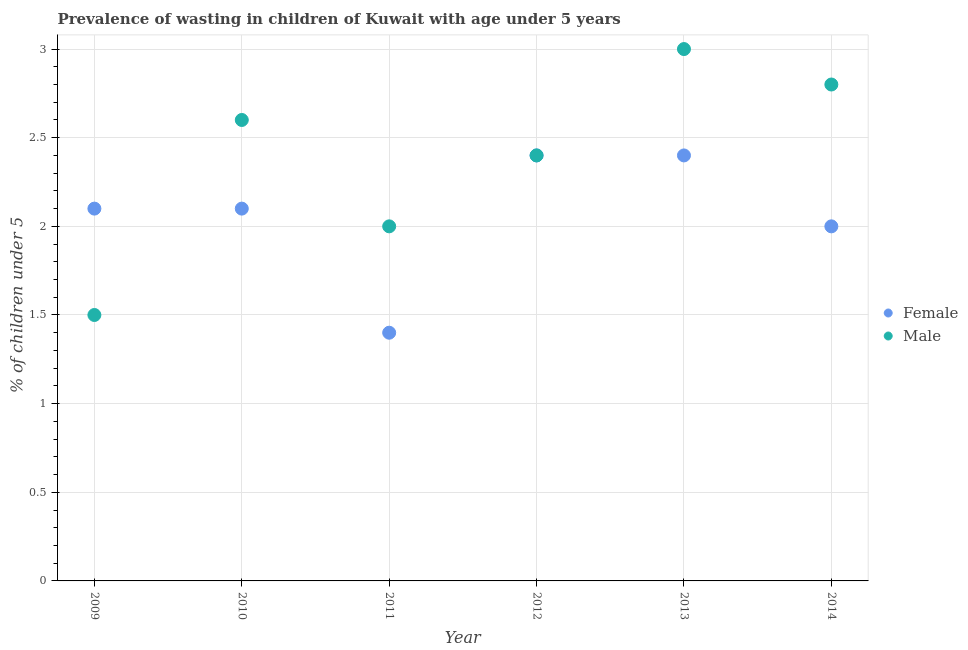What is the percentage of undernourished female children in 2012?
Keep it short and to the point. 2.4. Across all years, what is the maximum percentage of undernourished female children?
Provide a succinct answer. 2.4. Across all years, what is the minimum percentage of undernourished male children?
Offer a terse response. 1.5. In which year was the percentage of undernourished female children maximum?
Provide a succinct answer. 2012. What is the total percentage of undernourished female children in the graph?
Your answer should be compact. 12.4. What is the difference between the percentage of undernourished male children in 2010 and that in 2014?
Make the answer very short. -0.2. What is the difference between the percentage of undernourished female children in 2012 and the percentage of undernourished male children in 2009?
Your response must be concise. 0.9. What is the average percentage of undernourished female children per year?
Your response must be concise. 2.07. In the year 2013, what is the difference between the percentage of undernourished female children and percentage of undernourished male children?
Make the answer very short. -0.6. In how many years, is the percentage of undernourished male children greater than 2.2 %?
Your answer should be very brief. 4. What is the ratio of the percentage of undernourished male children in 2010 to that in 2011?
Provide a short and direct response. 1.3. Is the percentage of undernourished male children in 2013 less than that in 2014?
Offer a terse response. No. Does the percentage of undernourished female children monotonically increase over the years?
Keep it short and to the point. No. Is the percentage of undernourished female children strictly greater than the percentage of undernourished male children over the years?
Provide a short and direct response. No. How many dotlines are there?
Your answer should be compact. 2. How many years are there in the graph?
Provide a short and direct response. 6. Are the values on the major ticks of Y-axis written in scientific E-notation?
Keep it short and to the point. No. Does the graph contain any zero values?
Your response must be concise. No. What is the title of the graph?
Your response must be concise. Prevalence of wasting in children of Kuwait with age under 5 years. Does "Secondary education" appear as one of the legend labels in the graph?
Give a very brief answer. No. What is the label or title of the X-axis?
Provide a succinct answer. Year. What is the label or title of the Y-axis?
Make the answer very short.  % of children under 5. What is the  % of children under 5 in Female in 2009?
Provide a succinct answer. 2.1. What is the  % of children under 5 of Female in 2010?
Offer a terse response. 2.1. What is the  % of children under 5 in Male in 2010?
Give a very brief answer. 2.6. What is the  % of children under 5 in Female in 2011?
Ensure brevity in your answer.  1.4. What is the  % of children under 5 of Male in 2011?
Provide a short and direct response. 2. What is the  % of children under 5 in Female in 2012?
Make the answer very short. 2.4. What is the  % of children under 5 in Male in 2012?
Offer a terse response. 2.4. What is the  % of children under 5 of Female in 2013?
Make the answer very short. 2.4. What is the  % of children under 5 of Female in 2014?
Give a very brief answer. 2. What is the  % of children under 5 in Male in 2014?
Offer a very short reply. 2.8. Across all years, what is the maximum  % of children under 5 in Female?
Give a very brief answer. 2.4. Across all years, what is the minimum  % of children under 5 of Female?
Offer a very short reply. 1.4. Across all years, what is the minimum  % of children under 5 in Male?
Provide a succinct answer. 1.5. What is the total  % of children under 5 in Female in the graph?
Give a very brief answer. 12.4. What is the difference between the  % of children under 5 in Female in 2009 and that in 2010?
Offer a very short reply. 0. What is the difference between the  % of children under 5 in Female in 2009 and that in 2011?
Keep it short and to the point. 0.7. What is the difference between the  % of children under 5 of Male in 2009 and that in 2013?
Offer a terse response. -1.5. What is the difference between the  % of children under 5 of Female in 2010 and that in 2011?
Your answer should be very brief. 0.7. What is the difference between the  % of children under 5 of Male in 2010 and that in 2012?
Offer a very short reply. 0.2. What is the difference between the  % of children under 5 in Female in 2010 and that in 2013?
Ensure brevity in your answer.  -0.3. What is the difference between the  % of children under 5 in Female in 2010 and that in 2014?
Keep it short and to the point. 0.1. What is the difference between the  % of children under 5 in Male in 2011 and that in 2012?
Provide a succinct answer. -0.4. What is the difference between the  % of children under 5 in Male in 2011 and that in 2014?
Make the answer very short. -0.8. What is the difference between the  % of children under 5 in Female in 2012 and that in 2013?
Keep it short and to the point. 0. What is the difference between the  % of children under 5 in Male in 2012 and that in 2013?
Offer a terse response. -0.6. What is the difference between the  % of children under 5 of Female in 2012 and that in 2014?
Your answer should be compact. 0.4. What is the difference between the  % of children under 5 of Male in 2012 and that in 2014?
Offer a terse response. -0.4. What is the difference between the  % of children under 5 of Female in 2013 and that in 2014?
Keep it short and to the point. 0.4. What is the difference between the  % of children under 5 in Male in 2013 and that in 2014?
Give a very brief answer. 0.2. What is the difference between the  % of children under 5 in Female in 2009 and the  % of children under 5 in Male in 2011?
Your response must be concise. 0.1. What is the difference between the  % of children under 5 in Female in 2009 and the  % of children under 5 in Male in 2013?
Your answer should be very brief. -0.9. What is the difference between the  % of children under 5 of Female in 2009 and the  % of children under 5 of Male in 2014?
Give a very brief answer. -0.7. What is the difference between the  % of children under 5 of Female in 2010 and the  % of children under 5 of Male in 2012?
Keep it short and to the point. -0.3. What is the difference between the  % of children under 5 in Female in 2010 and the  % of children under 5 in Male in 2013?
Your answer should be compact. -0.9. What is the difference between the  % of children under 5 of Female in 2012 and the  % of children under 5 of Male in 2013?
Keep it short and to the point. -0.6. What is the difference between the  % of children under 5 in Female in 2012 and the  % of children under 5 in Male in 2014?
Your answer should be compact. -0.4. What is the difference between the  % of children under 5 in Female in 2013 and the  % of children under 5 in Male in 2014?
Your answer should be compact. -0.4. What is the average  % of children under 5 of Female per year?
Your answer should be very brief. 2.07. What is the average  % of children under 5 in Male per year?
Make the answer very short. 2.38. In the year 2009, what is the difference between the  % of children under 5 of Female and  % of children under 5 of Male?
Make the answer very short. 0.6. What is the ratio of the  % of children under 5 of Male in 2009 to that in 2010?
Offer a terse response. 0.58. What is the ratio of the  % of children under 5 of Male in 2009 to that in 2011?
Ensure brevity in your answer.  0.75. What is the ratio of the  % of children under 5 in Male in 2009 to that in 2014?
Your answer should be very brief. 0.54. What is the ratio of the  % of children under 5 in Female in 2010 to that in 2011?
Give a very brief answer. 1.5. What is the ratio of the  % of children under 5 in Female in 2010 to that in 2012?
Offer a terse response. 0.88. What is the ratio of the  % of children under 5 of Female in 2010 to that in 2013?
Ensure brevity in your answer.  0.88. What is the ratio of the  % of children under 5 of Male in 2010 to that in 2013?
Offer a very short reply. 0.87. What is the ratio of the  % of children under 5 of Male in 2010 to that in 2014?
Your response must be concise. 0.93. What is the ratio of the  % of children under 5 in Female in 2011 to that in 2012?
Offer a terse response. 0.58. What is the ratio of the  % of children under 5 in Female in 2011 to that in 2013?
Offer a very short reply. 0.58. What is the ratio of the  % of children under 5 of Female in 2011 to that in 2014?
Ensure brevity in your answer.  0.7. What is the ratio of the  % of children under 5 of Male in 2011 to that in 2014?
Ensure brevity in your answer.  0.71. What is the ratio of the  % of children under 5 in Female in 2012 to that in 2013?
Your answer should be compact. 1. What is the ratio of the  % of children under 5 of Female in 2012 to that in 2014?
Ensure brevity in your answer.  1.2. What is the ratio of the  % of children under 5 in Male in 2012 to that in 2014?
Keep it short and to the point. 0.86. What is the ratio of the  % of children under 5 of Female in 2013 to that in 2014?
Provide a short and direct response. 1.2. What is the ratio of the  % of children under 5 of Male in 2013 to that in 2014?
Offer a very short reply. 1.07. What is the difference between the highest and the second highest  % of children under 5 in Male?
Ensure brevity in your answer.  0.2. What is the difference between the highest and the lowest  % of children under 5 in Male?
Your response must be concise. 1.5. 